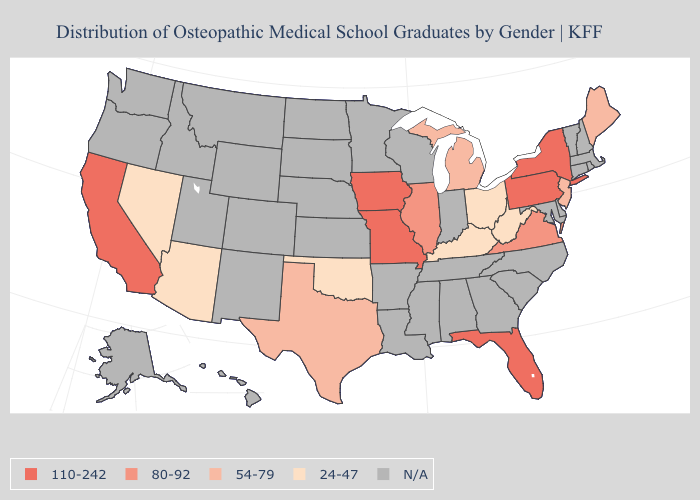Among the states that border Arkansas , does Oklahoma have the lowest value?
Quick response, please. Yes. Name the states that have a value in the range 110-242?
Short answer required. California, Florida, Iowa, Missouri, New York, Pennsylvania. What is the lowest value in the USA?
Quick response, please. 24-47. What is the highest value in the USA?
Answer briefly. 110-242. Name the states that have a value in the range 24-47?
Short answer required. Arizona, Kentucky, Nevada, Ohio, Oklahoma, West Virginia. Among the states that border Alabama , which have the lowest value?
Quick response, please. Florida. What is the highest value in states that border California?
Be succinct. 24-47. Which states have the highest value in the USA?
Give a very brief answer. California, Florida, Iowa, Missouri, New York, Pennsylvania. What is the value of Nebraska?
Keep it brief. N/A. Name the states that have a value in the range N/A?
Concise answer only. Alabama, Alaska, Arkansas, Colorado, Connecticut, Delaware, Georgia, Hawaii, Idaho, Indiana, Kansas, Louisiana, Maryland, Massachusetts, Minnesota, Mississippi, Montana, Nebraska, New Hampshire, New Mexico, North Carolina, North Dakota, Oregon, Rhode Island, South Carolina, South Dakota, Tennessee, Utah, Vermont, Washington, Wisconsin, Wyoming. Is the legend a continuous bar?
Write a very short answer. No. Name the states that have a value in the range 110-242?
Write a very short answer. California, Florida, Iowa, Missouri, New York, Pennsylvania. Name the states that have a value in the range 54-79?
Be succinct. Maine, Michigan, New Jersey, Texas. Name the states that have a value in the range 80-92?
Keep it brief. Illinois, Virginia. 